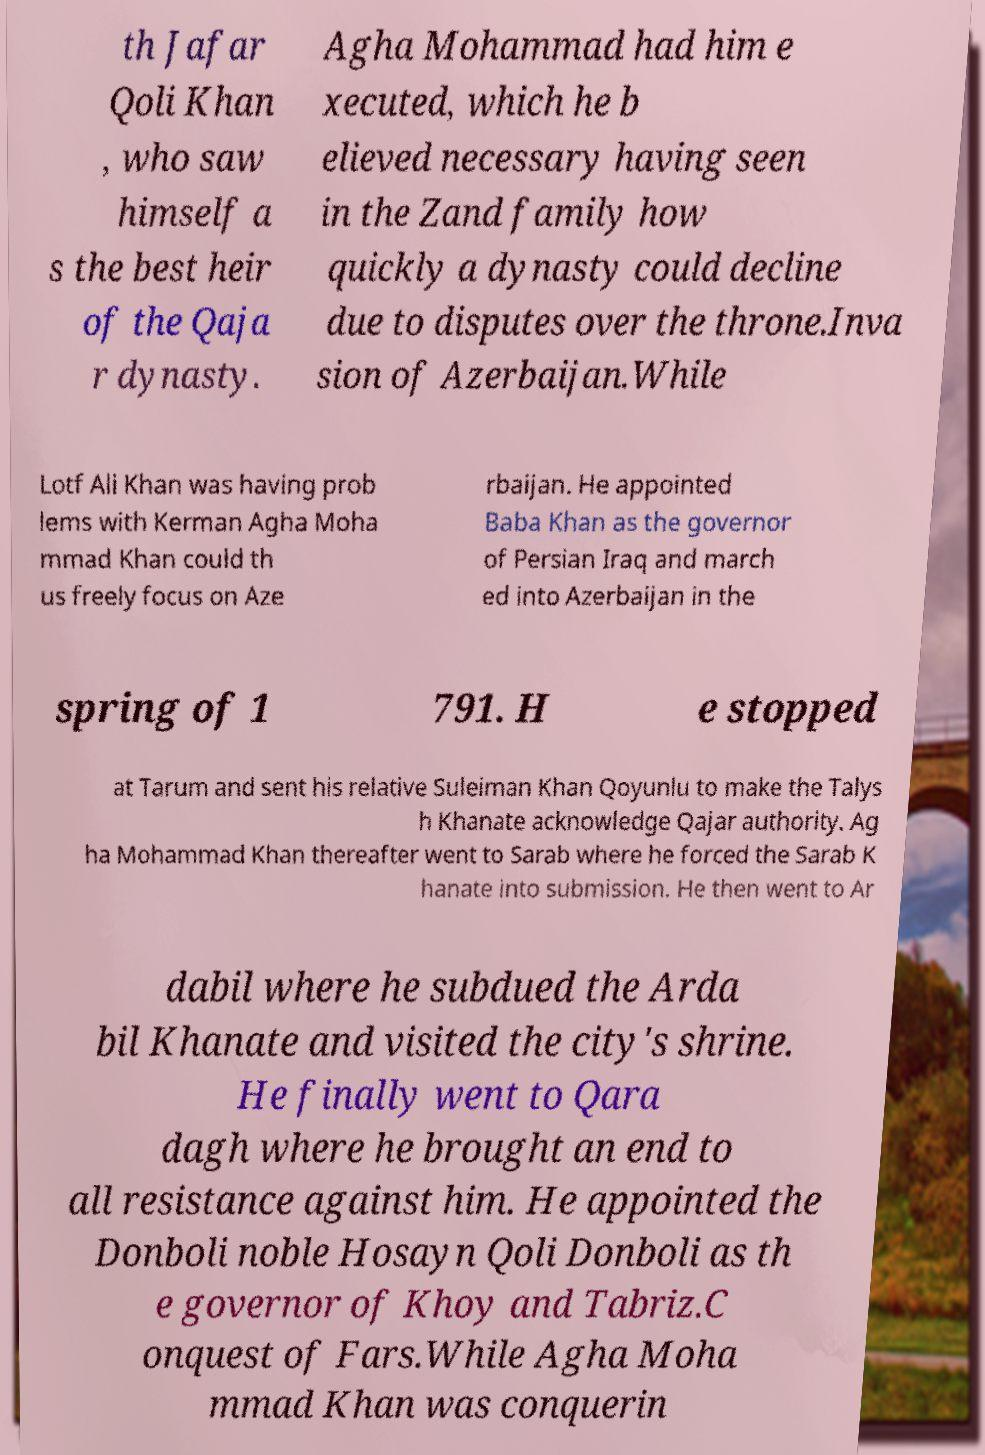Can you read and provide the text displayed in the image?This photo seems to have some interesting text. Can you extract and type it out for me? th Jafar Qoli Khan , who saw himself a s the best heir of the Qaja r dynasty. Agha Mohammad had him e xecuted, which he b elieved necessary having seen in the Zand family how quickly a dynasty could decline due to disputes over the throne.Inva sion of Azerbaijan.While Lotf Ali Khan was having prob lems with Kerman Agha Moha mmad Khan could th us freely focus on Aze rbaijan. He appointed Baba Khan as the governor of Persian Iraq and march ed into Azerbaijan in the spring of 1 791. H e stopped at Tarum and sent his relative Suleiman Khan Qoyunlu to make the Talys h Khanate acknowledge Qajar authority. Ag ha Mohammad Khan thereafter went to Sarab where he forced the Sarab K hanate into submission. He then went to Ar dabil where he subdued the Arda bil Khanate and visited the city's shrine. He finally went to Qara dagh where he brought an end to all resistance against him. He appointed the Donboli noble Hosayn Qoli Donboli as th e governor of Khoy and Tabriz.C onquest of Fars.While Agha Moha mmad Khan was conquerin 